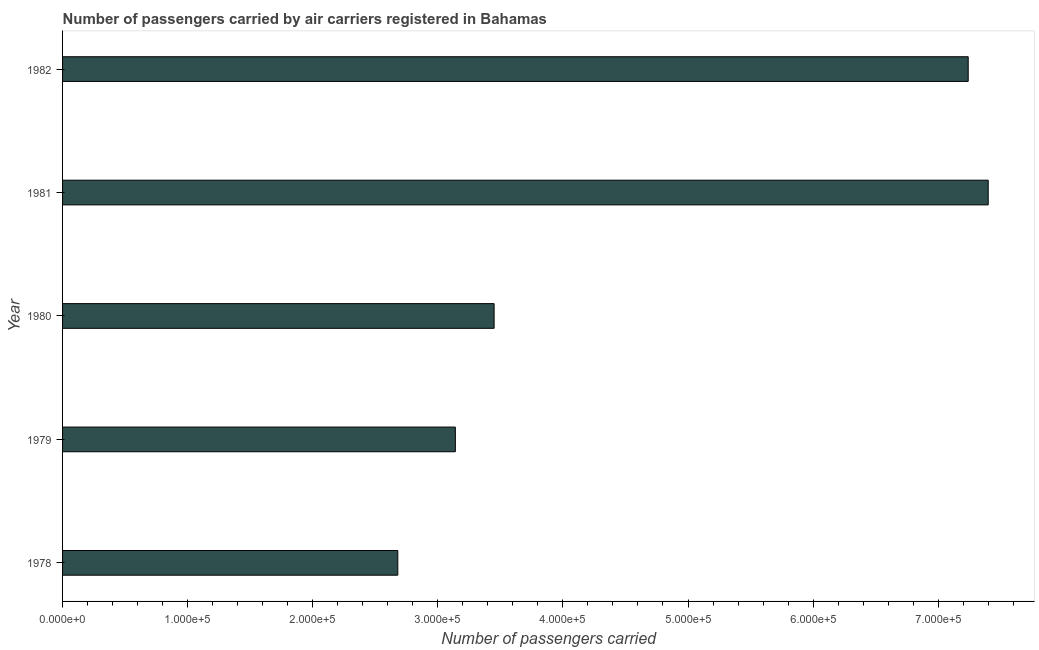Does the graph contain any zero values?
Your answer should be very brief. No. Does the graph contain grids?
Give a very brief answer. No. What is the title of the graph?
Your response must be concise. Number of passengers carried by air carriers registered in Bahamas. What is the label or title of the X-axis?
Ensure brevity in your answer.  Number of passengers carried. What is the label or title of the Y-axis?
Provide a short and direct response. Year. What is the number of passengers carried in 1978?
Provide a short and direct response. 2.68e+05. Across all years, what is the maximum number of passengers carried?
Provide a succinct answer. 7.40e+05. Across all years, what is the minimum number of passengers carried?
Your answer should be very brief. 2.68e+05. In which year was the number of passengers carried minimum?
Provide a short and direct response. 1978. What is the sum of the number of passengers carried?
Your answer should be very brief. 2.39e+06. What is the difference between the number of passengers carried in 1980 and 1982?
Provide a short and direct response. -3.79e+05. What is the average number of passengers carried per year?
Offer a terse response. 4.78e+05. What is the median number of passengers carried?
Ensure brevity in your answer.  3.45e+05. In how many years, is the number of passengers carried greater than 420000 ?
Make the answer very short. 2. What is the ratio of the number of passengers carried in 1980 to that in 1981?
Your answer should be compact. 0.47. Is the number of passengers carried in 1979 less than that in 1981?
Your answer should be compact. Yes. Is the difference between the number of passengers carried in 1979 and 1982 greater than the difference between any two years?
Offer a very short reply. No. What is the difference between the highest and the second highest number of passengers carried?
Your response must be concise. 1.60e+04. Is the sum of the number of passengers carried in 1980 and 1982 greater than the maximum number of passengers carried across all years?
Your response must be concise. Yes. What is the difference between the highest and the lowest number of passengers carried?
Your answer should be very brief. 4.72e+05. In how many years, is the number of passengers carried greater than the average number of passengers carried taken over all years?
Keep it short and to the point. 2. How many bars are there?
Provide a short and direct response. 5. What is the difference between two consecutive major ticks on the X-axis?
Your answer should be very brief. 1.00e+05. Are the values on the major ticks of X-axis written in scientific E-notation?
Ensure brevity in your answer.  Yes. What is the Number of passengers carried of 1978?
Give a very brief answer. 2.68e+05. What is the Number of passengers carried in 1979?
Your answer should be compact. 3.14e+05. What is the Number of passengers carried in 1980?
Ensure brevity in your answer.  3.45e+05. What is the Number of passengers carried of 1981?
Offer a terse response. 7.40e+05. What is the Number of passengers carried of 1982?
Provide a short and direct response. 7.24e+05. What is the difference between the Number of passengers carried in 1978 and 1979?
Your answer should be very brief. -4.60e+04. What is the difference between the Number of passengers carried in 1978 and 1980?
Your response must be concise. -7.70e+04. What is the difference between the Number of passengers carried in 1978 and 1981?
Make the answer very short. -4.72e+05. What is the difference between the Number of passengers carried in 1978 and 1982?
Ensure brevity in your answer.  -4.56e+05. What is the difference between the Number of passengers carried in 1979 and 1980?
Ensure brevity in your answer.  -3.10e+04. What is the difference between the Number of passengers carried in 1979 and 1981?
Provide a succinct answer. -4.26e+05. What is the difference between the Number of passengers carried in 1979 and 1982?
Offer a terse response. -4.10e+05. What is the difference between the Number of passengers carried in 1980 and 1981?
Your answer should be very brief. -3.95e+05. What is the difference between the Number of passengers carried in 1980 and 1982?
Provide a succinct answer. -3.79e+05. What is the difference between the Number of passengers carried in 1981 and 1982?
Give a very brief answer. 1.60e+04. What is the ratio of the Number of passengers carried in 1978 to that in 1979?
Your answer should be very brief. 0.85. What is the ratio of the Number of passengers carried in 1978 to that in 1980?
Ensure brevity in your answer.  0.78. What is the ratio of the Number of passengers carried in 1978 to that in 1981?
Offer a terse response. 0.36. What is the ratio of the Number of passengers carried in 1978 to that in 1982?
Give a very brief answer. 0.37. What is the ratio of the Number of passengers carried in 1979 to that in 1980?
Your response must be concise. 0.91. What is the ratio of the Number of passengers carried in 1979 to that in 1981?
Give a very brief answer. 0.42. What is the ratio of the Number of passengers carried in 1979 to that in 1982?
Offer a terse response. 0.43. What is the ratio of the Number of passengers carried in 1980 to that in 1981?
Offer a very short reply. 0.47. What is the ratio of the Number of passengers carried in 1980 to that in 1982?
Your answer should be compact. 0.48. What is the ratio of the Number of passengers carried in 1981 to that in 1982?
Keep it short and to the point. 1.02. 